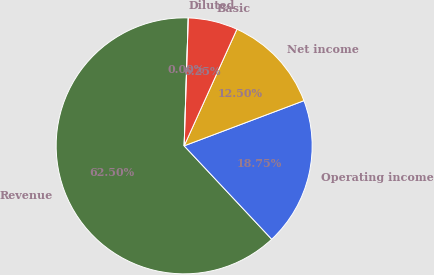<chart> <loc_0><loc_0><loc_500><loc_500><pie_chart><fcel>Revenue<fcel>Operating income<fcel>Net income<fcel>Basic<fcel>Diluted<nl><fcel>62.5%<fcel>18.75%<fcel>12.5%<fcel>6.25%<fcel>0.0%<nl></chart> 